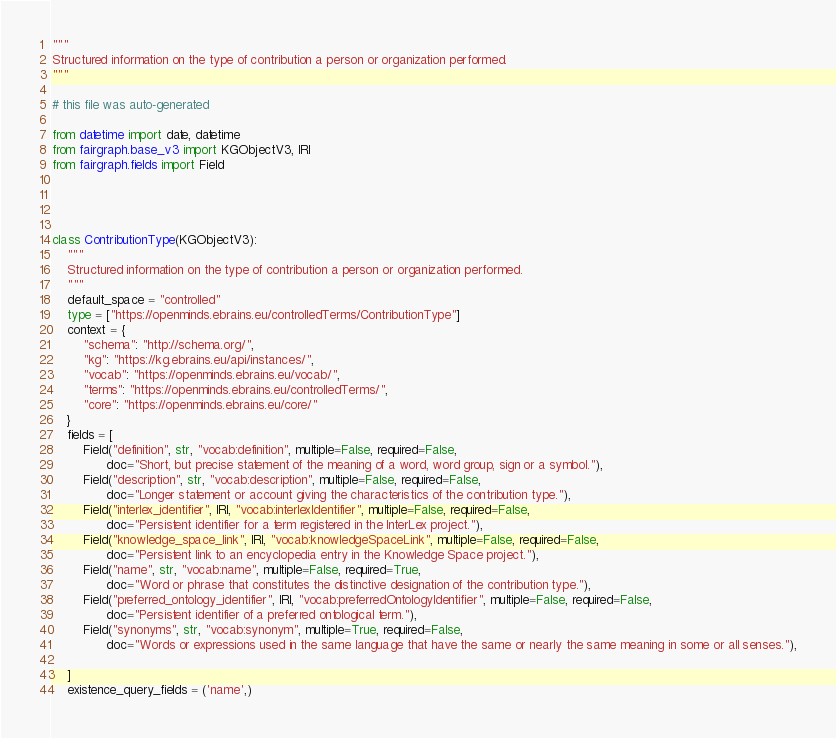Convert code to text. <code><loc_0><loc_0><loc_500><loc_500><_Python_>"""
Structured information on the type of contribution a person or organization performed.
"""

# this file was auto-generated

from datetime import date, datetime
from fairgraph.base_v3 import KGObjectV3, IRI
from fairgraph.fields import Field




class ContributionType(KGObjectV3):
    """
    Structured information on the type of contribution a person or organization performed.
    """
    default_space = "controlled"
    type = ["https://openminds.ebrains.eu/controlledTerms/ContributionType"]
    context = {
        "schema": "http://schema.org/",
        "kg": "https://kg.ebrains.eu/api/instances/",
        "vocab": "https://openminds.ebrains.eu/vocab/",
        "terms": "https://openminds.ebrains.eu/controlledTerms/",
        "core": "https://openminds.ebrains.eu/core/"
    }
    fields = [
        Field("definition", str, "vocab:definition", multiple=False, required=False,
              doc="Short, but precise statement of the meaning of a word, word group, sign or a symbol."),
        Field("description", str, "vocab:description", multiple=False, required=False,
              doc="Longer statement or account giving the characteristics of the contribution type."),
        Field("interlex_identifier", IRI, "vocab:interlexIdentifier", multiple=False, required=False,
              doc="Persistent identifier for a term registered in the InterLex project."),
        Field("knowledge_space_link", IRI, "vocab:knowledgeSpaceLink", multiple=False, required=False,
              doc="Persistent link to an encyclopedia entry in the Knowledge Space project."),
        Field("name", str, "vocab:name", multiple=False, required=True,
              doc="Word or phrase that constitutes the distinctive designation of the contribution type."),
        Field("preferred_ontology_identifier", IRI, "vocab:preferredOntologyIdentifier", multiple=False, required=False,
              doc="Persistent identifier of a preferred ontological term."),
        Field("synonyms", str, "vocab:synonym", multiple=True, required=False,
              doc="Words or expressions used in the same language that have the same or nearly the same meaning in some or all senses."),
        
    ]
    existence_query_fields = ('name',)

</code> 